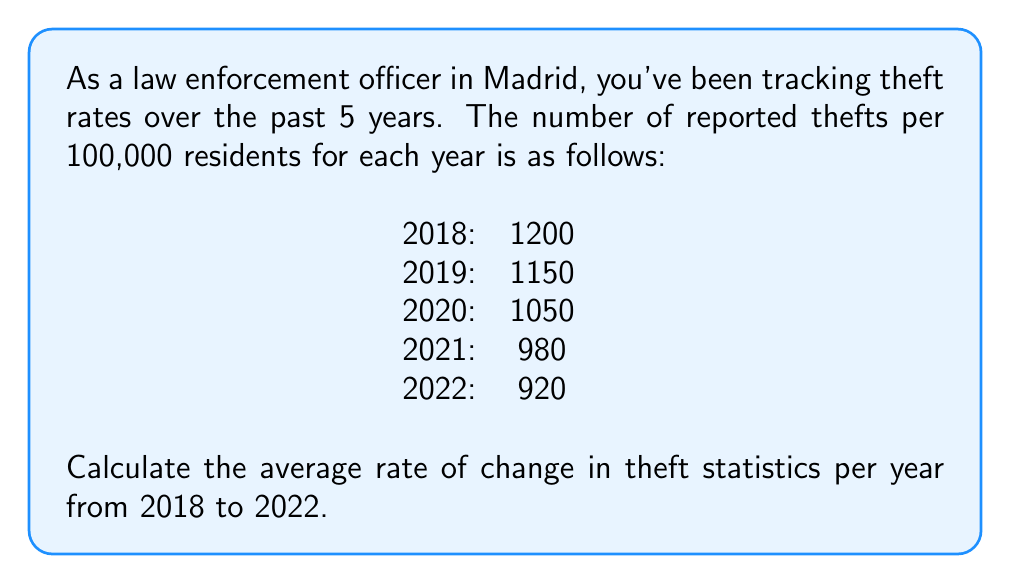Can you solve this math problem? To calculate the average rate of change, we'll use the formula:

$$ \text{Average rate of change} = \frac{\text{Change in y}}{\text{Change in x}} = \frac{y_2 - y_1}{x_2 - x_1} $$

Where:
$y_2$ is the final value (920 thefts per 100,000 in 2022)
$y_1$ is the initial value (1200 thefts per 100,000 in 2018)
$x_2$ is the final year (2022)
$x_1$ is the initial year (2018)

Let's plug in the values:

$$ \text{Average rate of change} = \frac{920 - 1200}{2022 - 2018} = \frac{-280}{4} = -70 $$

The negative sign indicates a decrease in theft rates.

Therefore, the average rate of change in theft statistics is -70 thefts per 100,000 residents per year from 2018 to 2022.
Answer: -70 thefts per 100,000 residents per year 